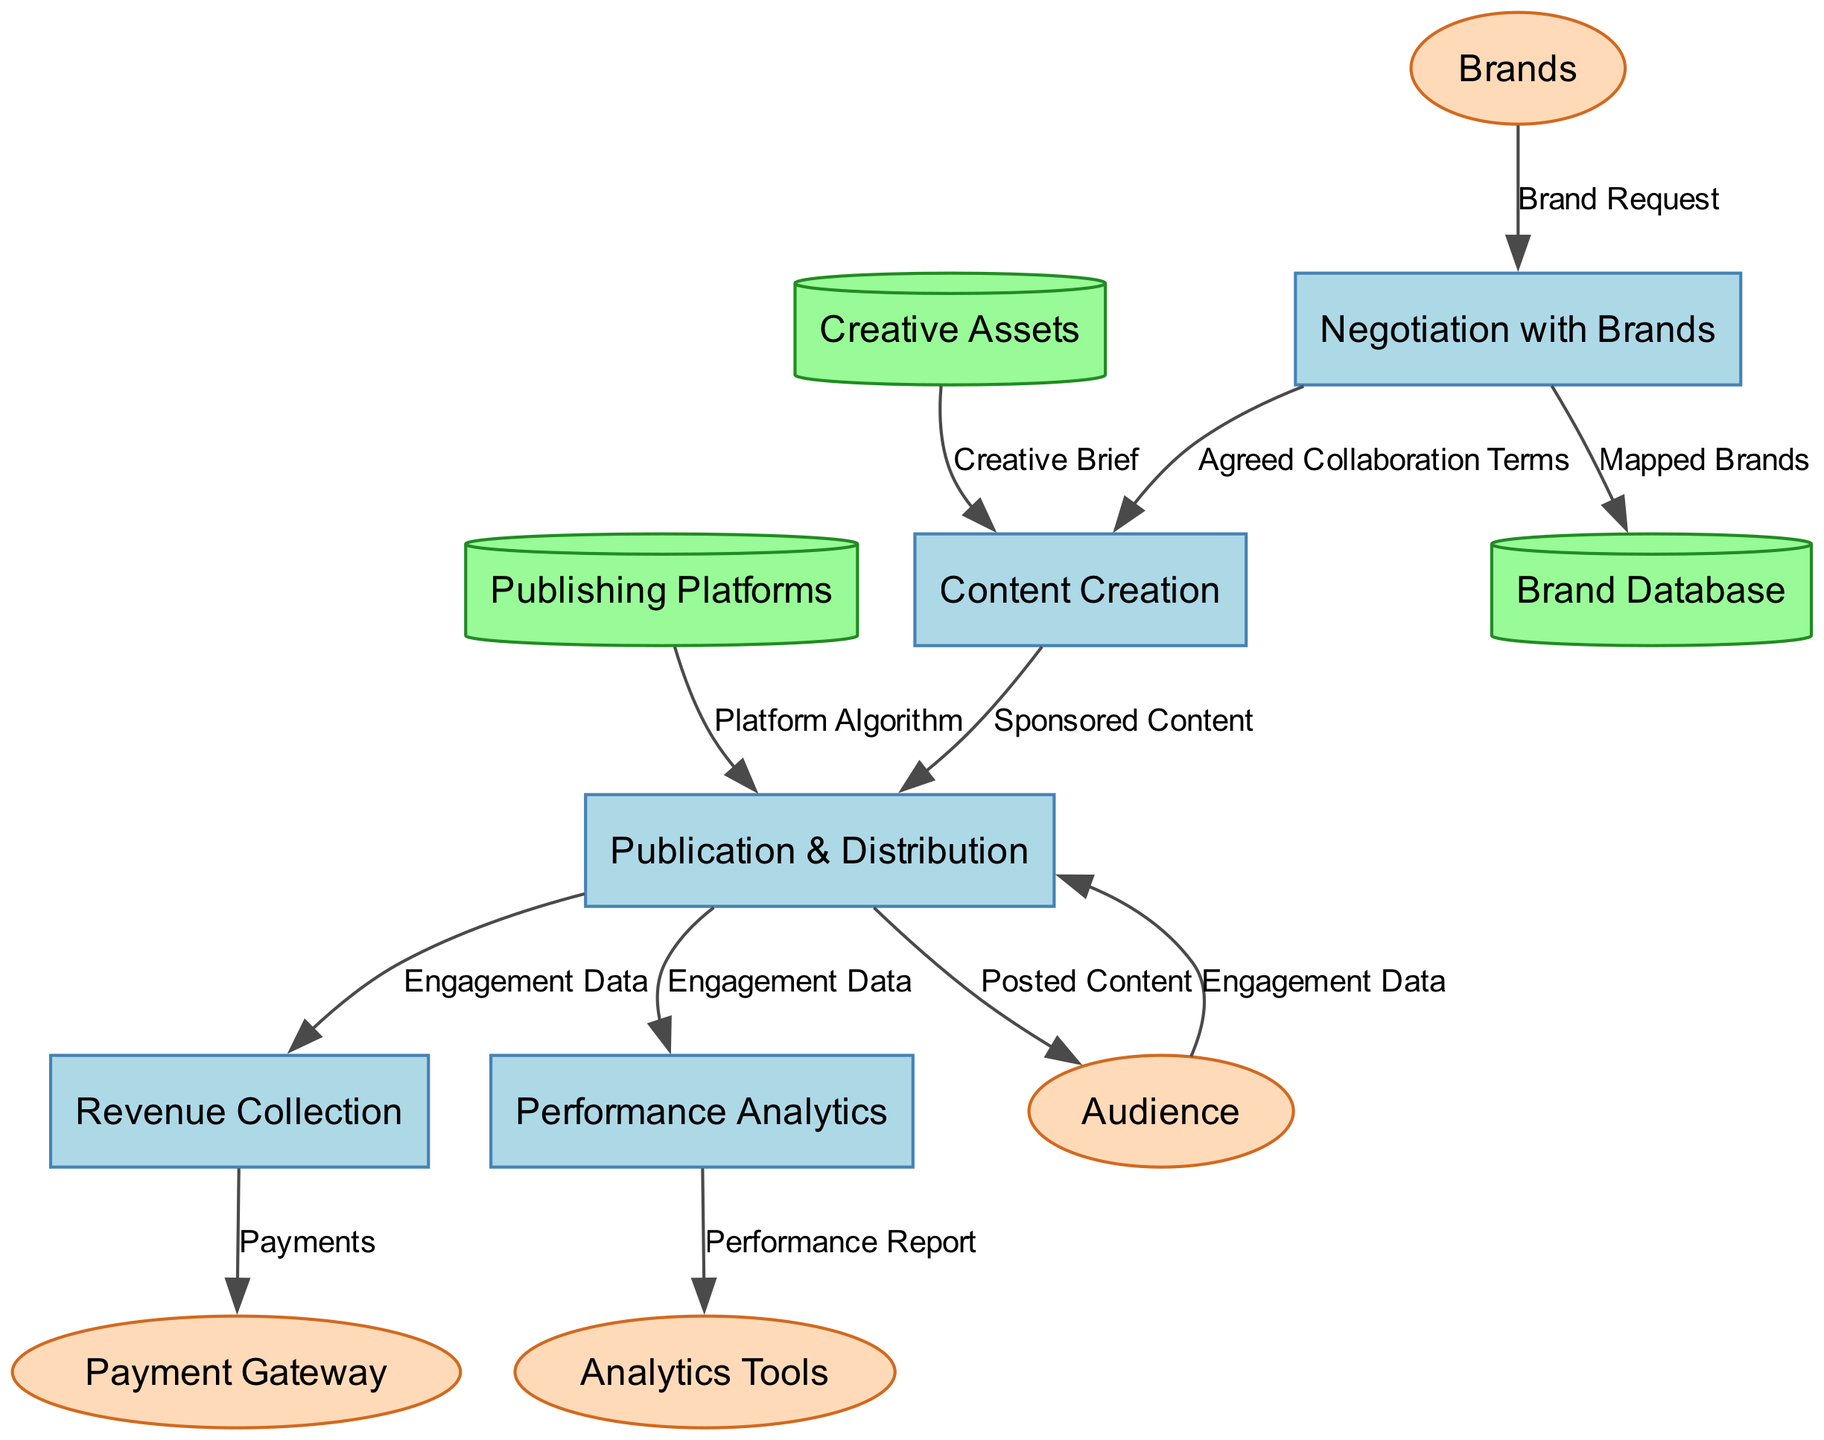What is the first process in the diagram? The first process is illustrated with the id "P1", which is labeled as "Negotiation with Brands".
Answer: Negotiation with Brands How many data stores are present in the diagram? There are three data stores listed in the diagram: Brand Database, Creative Assets, and Publishing Platforms.
Answer: 3 Which external entity provides the engagement data to the publication process? The engagement data is provided by the audience, which is represented as an external entity labeled "Audience".
Answer: Audience What is the output of the "Content Creation" process? The output from the "Content Creation" process (P2) is "Sponsored Content".
Answer: Sponsored Content Which process receives the "Payments" output? The "Revenue Collection" process (P4) is the one that outputs "Payments".
Answer: Revenue Collection What data does the "Performance Analytics" process generate? The "Performance Analytics" process (P5) generates the output "Performance Report".
Answer: Performance Report Which process utilizes the "Platform Algorithm" data store? The "Publication & Distribution" process (P3) utilizes the "Platform Algorithm" data store for its operations.
Answer: Publication & Distribution How many flows originate from the "Negotiation with Brands"? Two flows originate from the "Negotiation with Brands": one leads to "Brand Database" and the other to "Content Creation".
Answer: 2 What is the main purpose of the "Revenue Collection" process? The main purpose of the "Revenue Collection" process is to collect payments based on agreed terms and engagement data.
Answer: Payments 